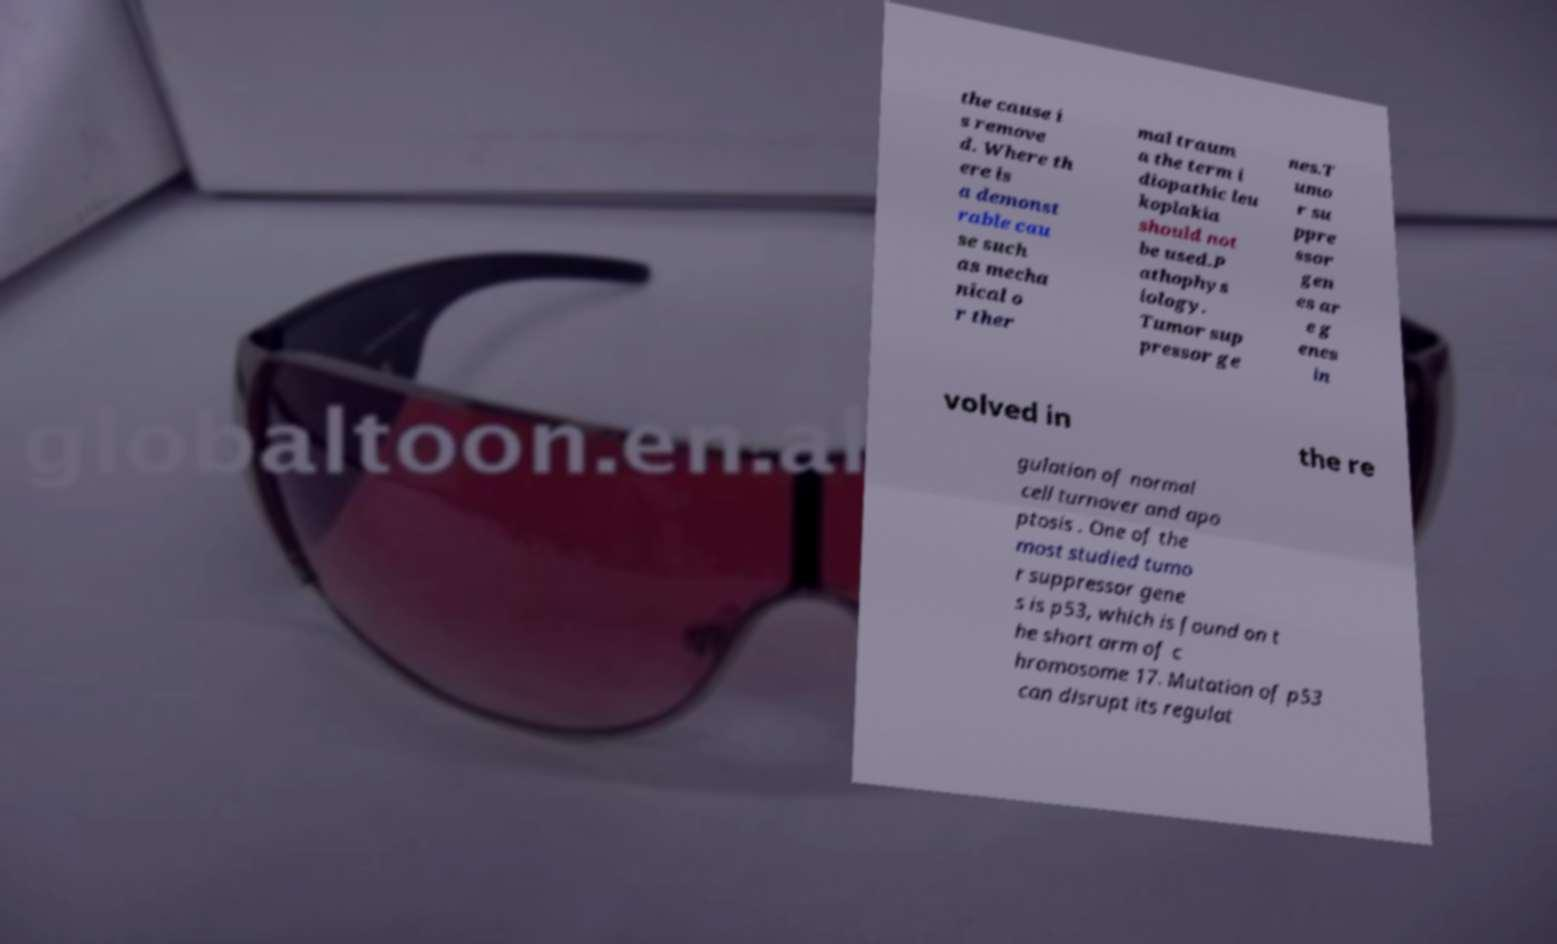There's text embedded in this image that I need extracted. Can you transcribe it verbatim? the cause i s remove d. Where th ere is a demonst rable cau se such as mecha nical o r ther mal traum a the term i diopathic leu koplakia should not be used.P athophys iology. Tumor sup pressor ge nes.T umo r su ppre ssor gen es ar e g enes in volved in the re gulation of normal cell turnover and apo ptosis . One of the most studied tumo r suppressor gene s is p53, which is found on t he short arm of c hromosome 17. Mutation of p53 can disrupt its regulat 